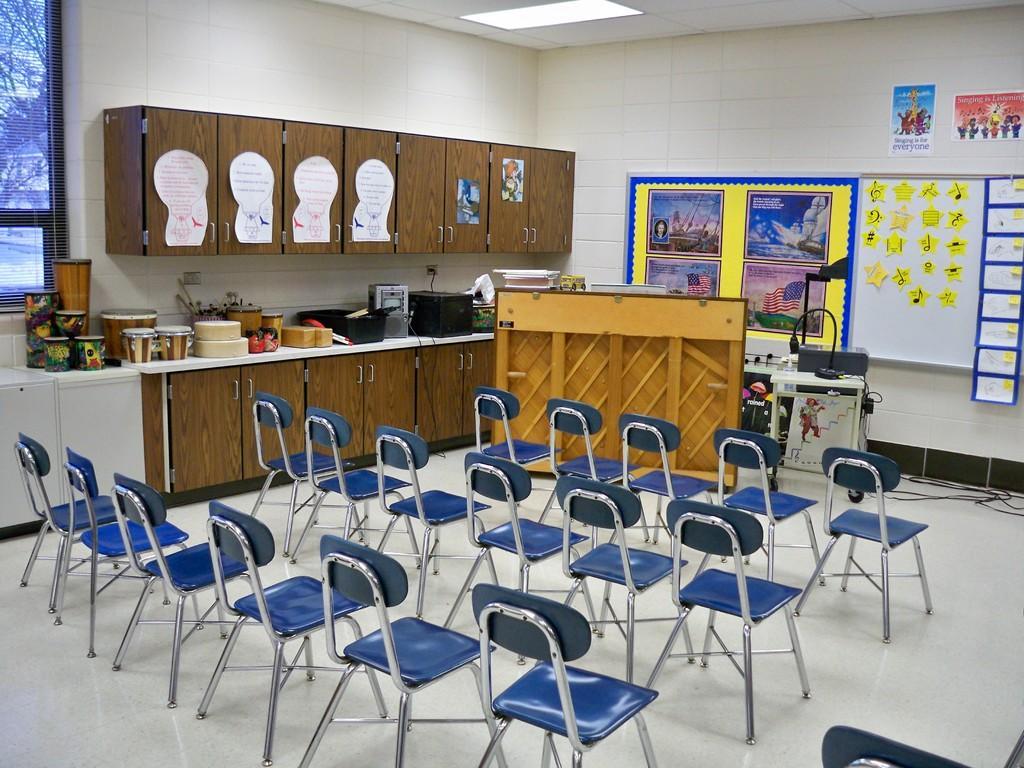Can you describe this image briefly? These are the empty chairs. I can see a table with a lamp and few other objects on it. These are the cupboards with doors. I can see posts attached to the cupboards. These are the musical instruments, tray and few other objects. This looks like a notice board with the papers attached to it. This is the ceiling light, which is attached to the roof. These are the cables. Here is the window. 